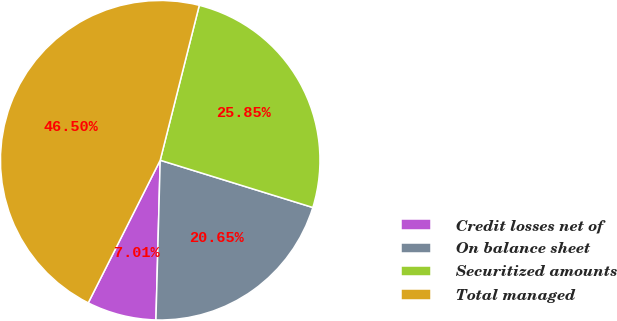Convert chart to OTSL. <chart><loc_0><loc_0><loc_500><loc_500><pie_chart><fcel>Credit losses net of<fcel>On balance sheet<fcel>Securitized amounts<fcel>Total managed<nl><fcel>7.01%<fcel>20.65%<fcel>25.85%<fcel>46.5%<nl></chart> 